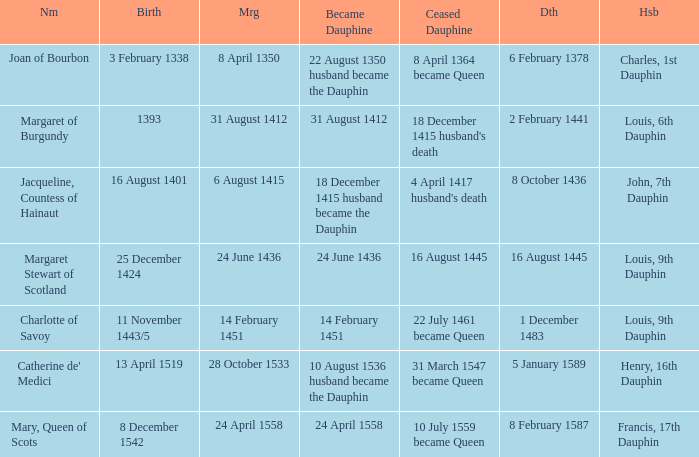When was became dauphine when birth is 1393? 31 August 1412. 